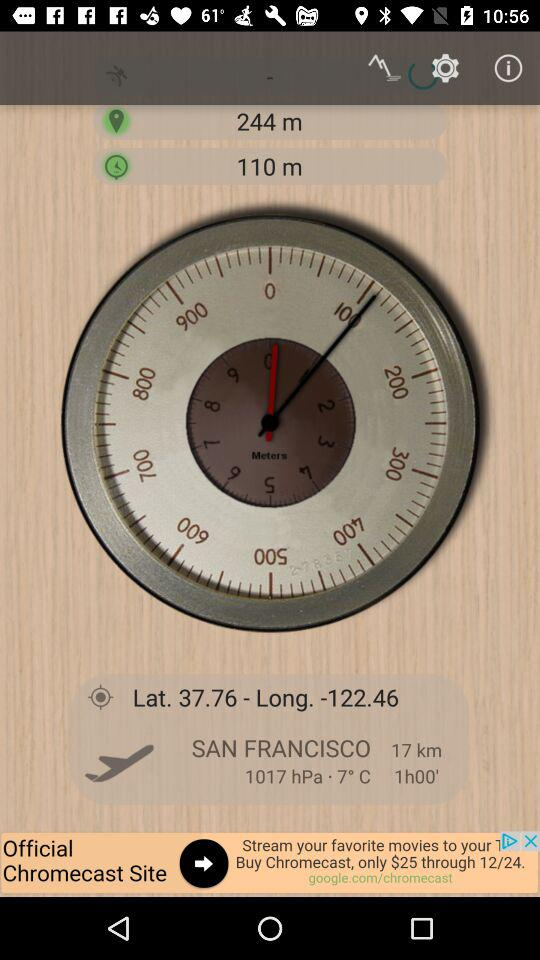What is the latitude? The latitude is 37.76. 